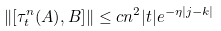Convert formula to latex. <formula><loc_0><loc_0><loc_500><loc_500>\| [ \tau _ { t } ^ { n } ( A ) , B ] \| \leq c n ^ { 2 } | t | e ^ { - \eta | j - k | }</formula> 